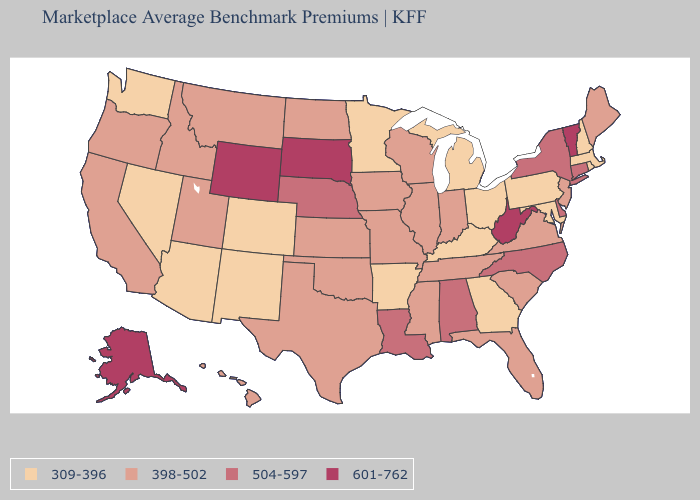How many symbols are there in the legend?
Concise answer only. 4. Name the states that have a value in the range 398-502?
Be succinct. California, Florida, Hawaii, Idaho, Illinois, Indiana, Iowa, Kansas, Maine, Mississippi, Missouri, Montana, New Jersey, North Dakota, Oklahoma, Oregon, South Carolina, Tennessee, Texas, Utah, Virginia, Wisconsin. Does Michigan have the lowest value in the MidWest?
Keep it brief. Yes. Name the states that have a value in the range 504-597?
Answer briefly. Alabama, Connecticut, Delaware, Louisiana, Nebraska, New York, North Carolina. Name the states that have a value in the range 398-502?
Short answer required. California, Florida, Hawaii, Idaho, Illinois, Indiana, Iowa, Kansas, Maine, Mississippi, Missouri, Montana, New Jersey, North Dakota, Oklahoma, Oregon, South Carolina, Tennessee, Texas, Utah, Virginia, Wisconsin. What is the value of Nebraska?
Give a very brief answer. 504-597. How many symbols are there in the legend?
Answer briefly. 4. Does Alaska have the highest value in the USA?
Concise answer only. Yes. Does Nevada have the same value as Rhode Island?
Give a very brief answer. Yes. Does Arizona have the same value as North Dakota?
Answer briefly. No. What is the highest value in the South ?
Quick response, please. 601-762. Does West Virginia have the highest value in the USA?
Give a very brief answer. Yes. What is the highest value in the Northeast ?
Short answer required. 601-762. 